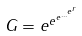Convert formula to latex. <formula><loc_0><loc_0><loc_500><loc_500>G = e ^ { e ^ { e ^ { \dots ^ { e ^ { r } } } } }</formula> 